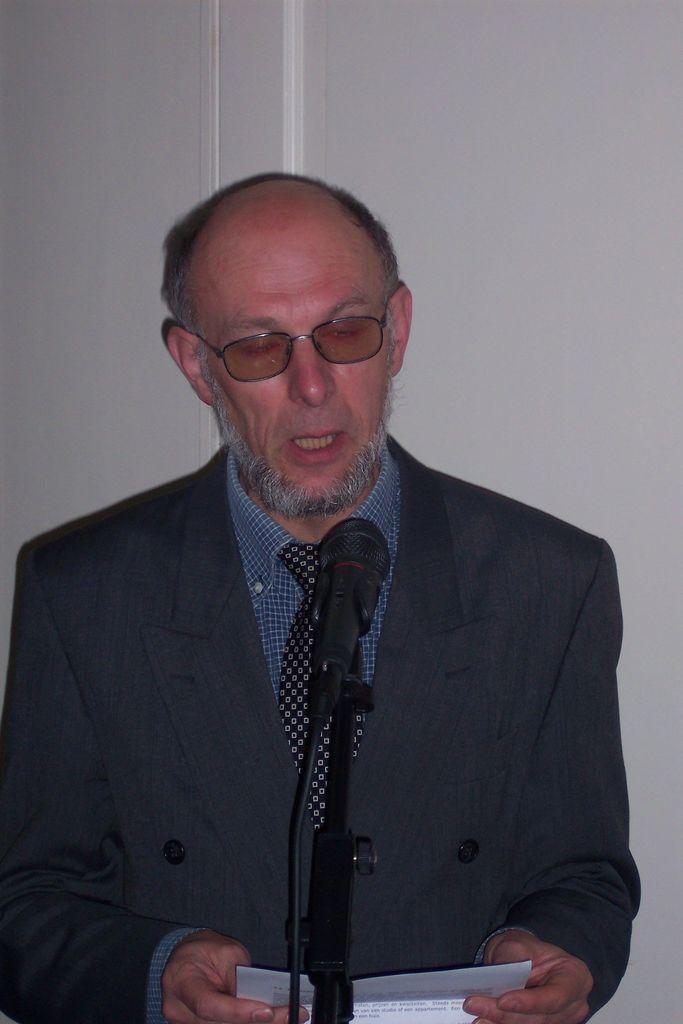Who is the main subject in the image? There is a man in the middle of the image. What is the man wearing? The man is wearing a coat and spectacles. What object is in front of the man? There is a mic in front of the man. What can be seen in the background of the image? There is a wall in the background of the image. How many hens are sitting on the man's shoulder in the image? There are no hens present in the image. What is the man's net worth based on the image? The image does not provide any information about the man's wealth. 